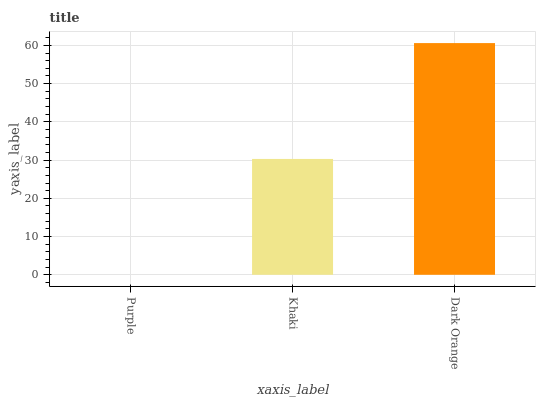Is Purple the minimum?
Answer yes or no. Yes. Is Dark Orange the maximum?
Answer yes or no. Yes. Is Khaki the minimum?
Answer yes or no. No. Is Khaki the maximum?
Answer yes or no. No. Is Khaki greater than Purple?
Answer yes or no. Yes. Is Purple less than Khaki?
Answer yes or no. Yes. Is Purple greater than Khaki?
Answer yes or no. No. Is Khaki less than Purple?
Answer yes or no. No. Is Khaki the high median?
Answer yes or no. Yes. Is Khaki the low median?
Answer yes or no. Yes. Is Purple the high median?
Answer yes or no. No. Is Dark Orange the low median?
Answer yes or no. No. 